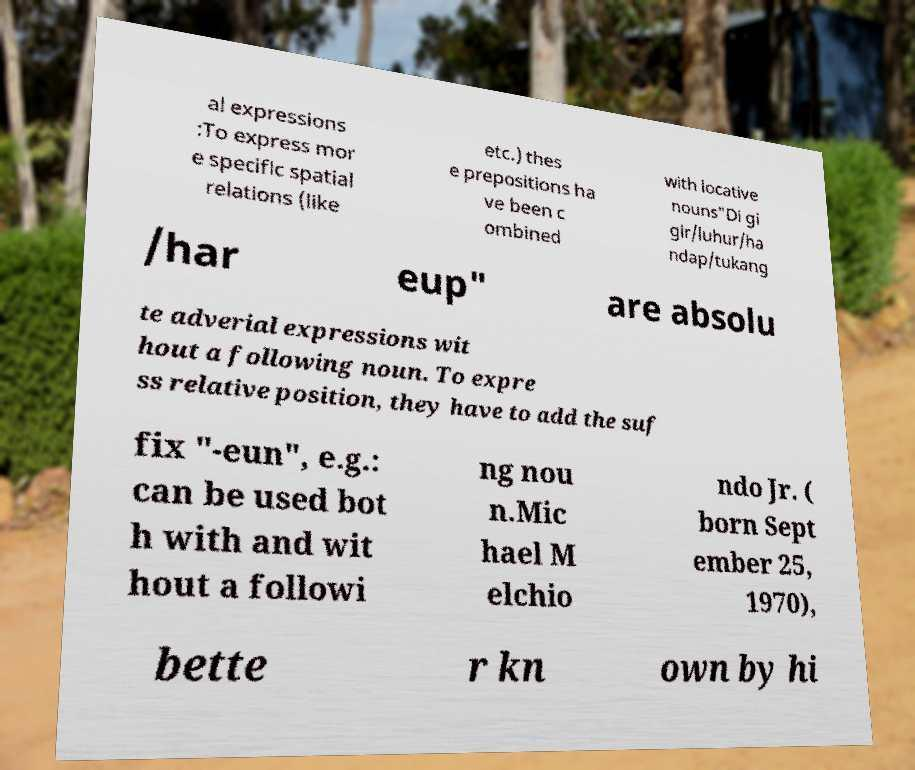Could you assist in decoding the text presented in this image and type it out clearly? al expressions :To express mor e specific spatial relations (like etc.) thes e prepositions ha ve been c ombined with locative nouns"Di gi gir/luhur/ha ndap/tukang /har eup" are absolu te adverial expressions wit hout a following noun. To expre ss relative position, they have to add the suf fix "-eun", e.g.: can be used bot h with and wit hout a followi ng nou n.Mic hael M elchio ndo Jr. ( born Sept ember 25, 1970), bette r kn own by hi 